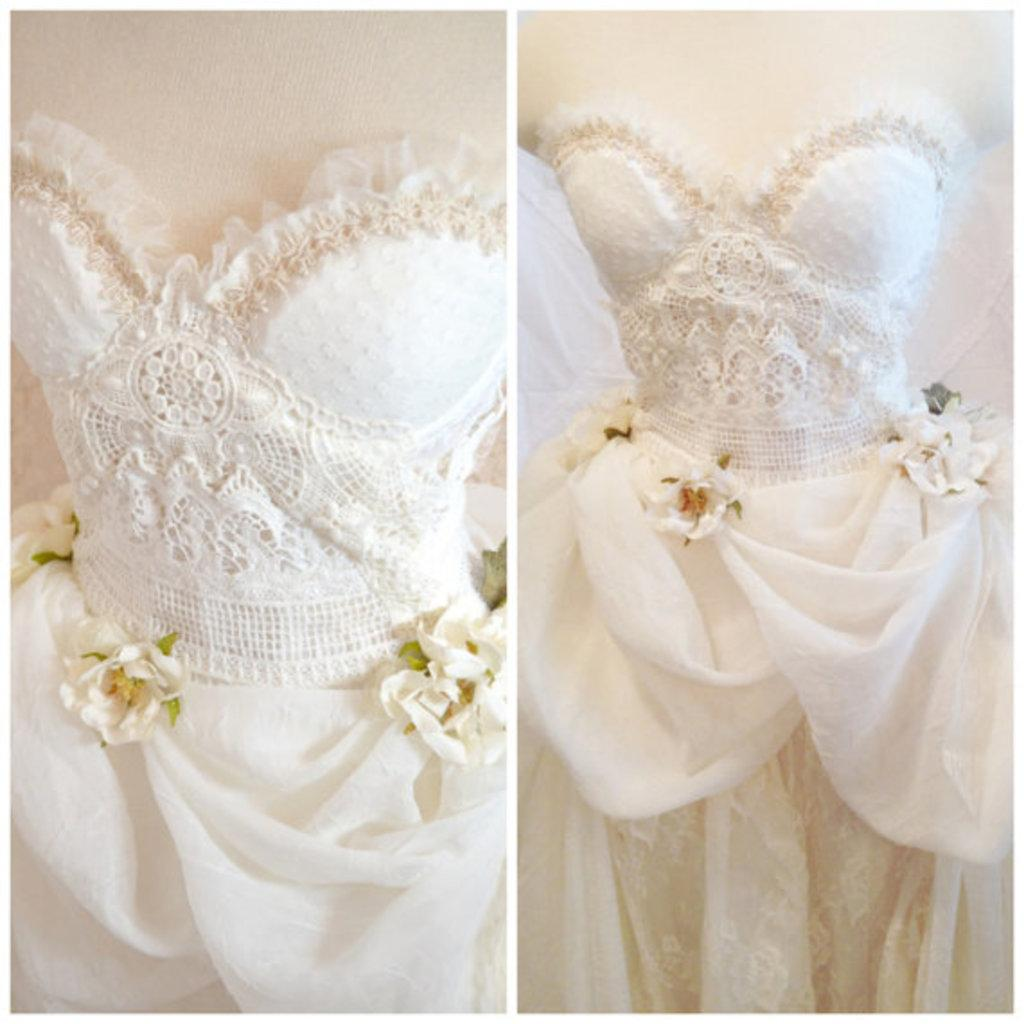What color is the cloth that is visible in the image? The cloth in the image is white. What type of headwear can be seen in the image? There is a hat in the image. What type of flora is present in the image? There are flowers in the image. What type of structure is visible in the image? There is a wall in the image. Can you describe the print on the bee's wings in the image? There is no bee present in the image, so it is not possible to describe any print on its wings. 